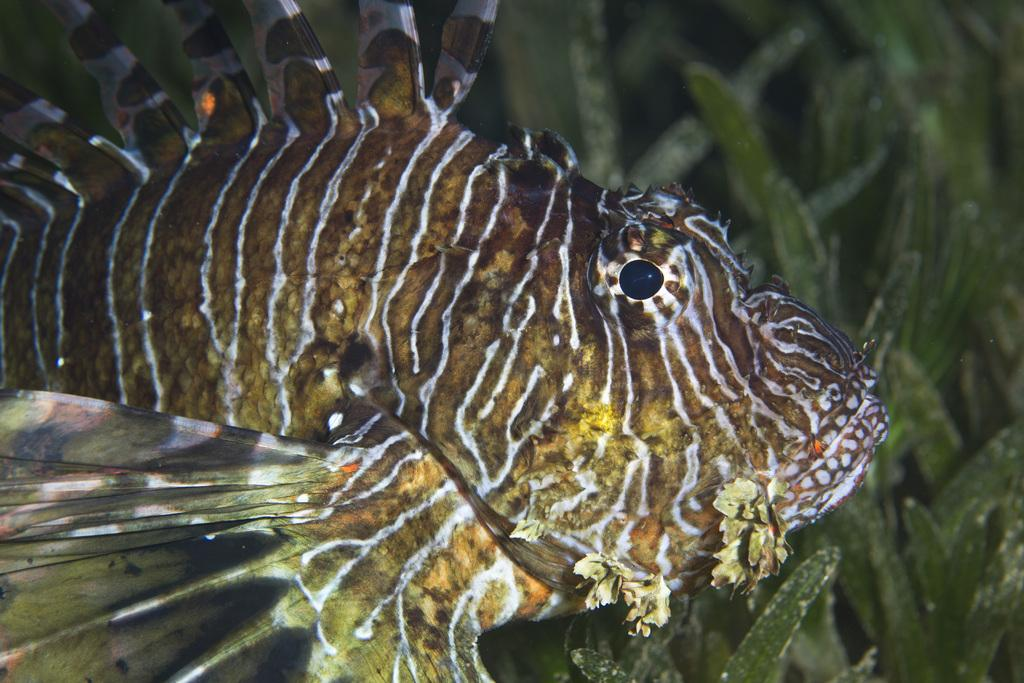What is the main subject of the image? The image depicts a water body. Are there any living creatures visible in the water body? Yes, there is a fish in the water body. What else can be seen in the image besides the water body and fish? There are leaves present in the image. What type of whistle can be heard coming from the fish in the image? There is no whistle present in the image, and the fish does not make any sounds. 